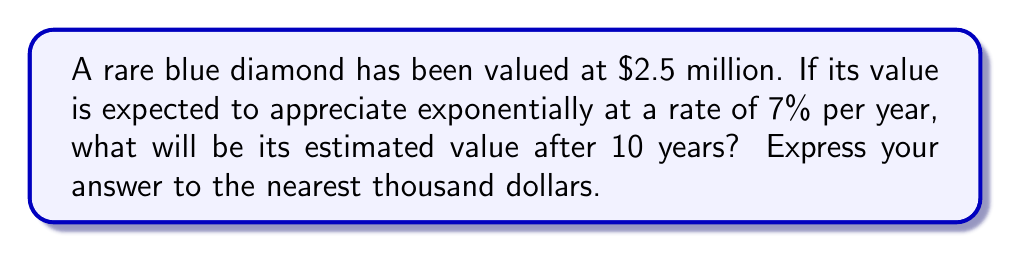Teach me how to tackle this problem. To solve this problem, we'll use the exponential growth formula:

$$A = P(1 + r)^t$$

Where:
$A$ = Final amount
$P$ = Principal (initial value)
$r$ = Annual rate of appreciation (as a decimal)
$t$ = Time in years

Given:
$P = \$2,500,000$
$r = 7\% = 0.07$
$t = 10$ years

Let's substitute these values into the formula:

$$A = 2,500,000(1 + 0.07)^{10}$$

Now, let's calculate step by step:

1) First, calculate $(1 + 0.07)^{10}$:
   $$(1.07)^{10} \approx 1.9672$$

2) Multiply this by the initial value:
   $$2,500,000 \times 1.9672 \approx 4,918,000$$

3) Rounding to the nearest thousand:
   $$4,918,000 \approx 4,918,000$$

Thus, the estimated value of the blue diamond after 10 years will be $4,918,000.
Answer: $4,918,000 